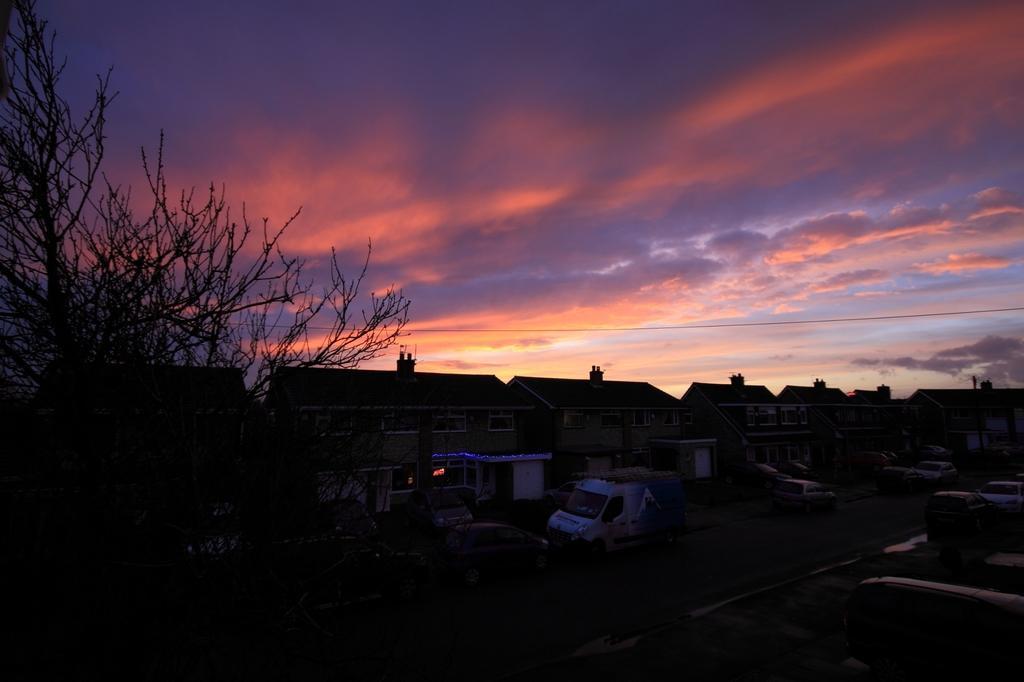How would you summarize this image in a sentence or two? In this picture we can see the sky with clouds, buildings and vehicles on the road. On the left side of the picture we can see a bare tree. Bottom portion of the picture is dark. 